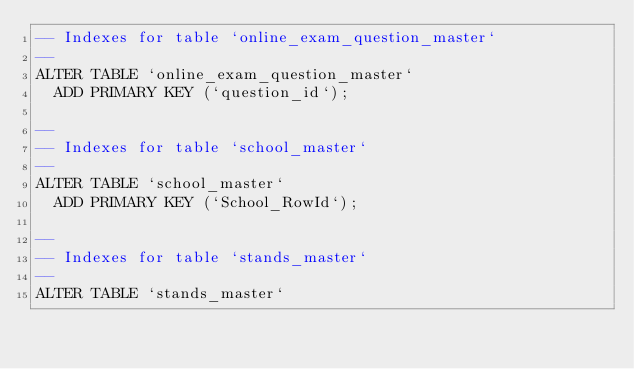<code> <loc_0><loc_0><loc_500><loc_500><_SQL_>-- Indexes for table `online_exam_question_master`
--
ALTER TABLE `online_exam_question_master`
  ADD PRIMARY KEY (`question_id`);

--
-- Indexes for table `school_master`
--
ALTER TABLE `school_master`
  ADD PRIMARY KEY (`School_RowId`);

--
-- Indexes for table `stands_master`
--
ALTER TABLE `stands_master`</code> 